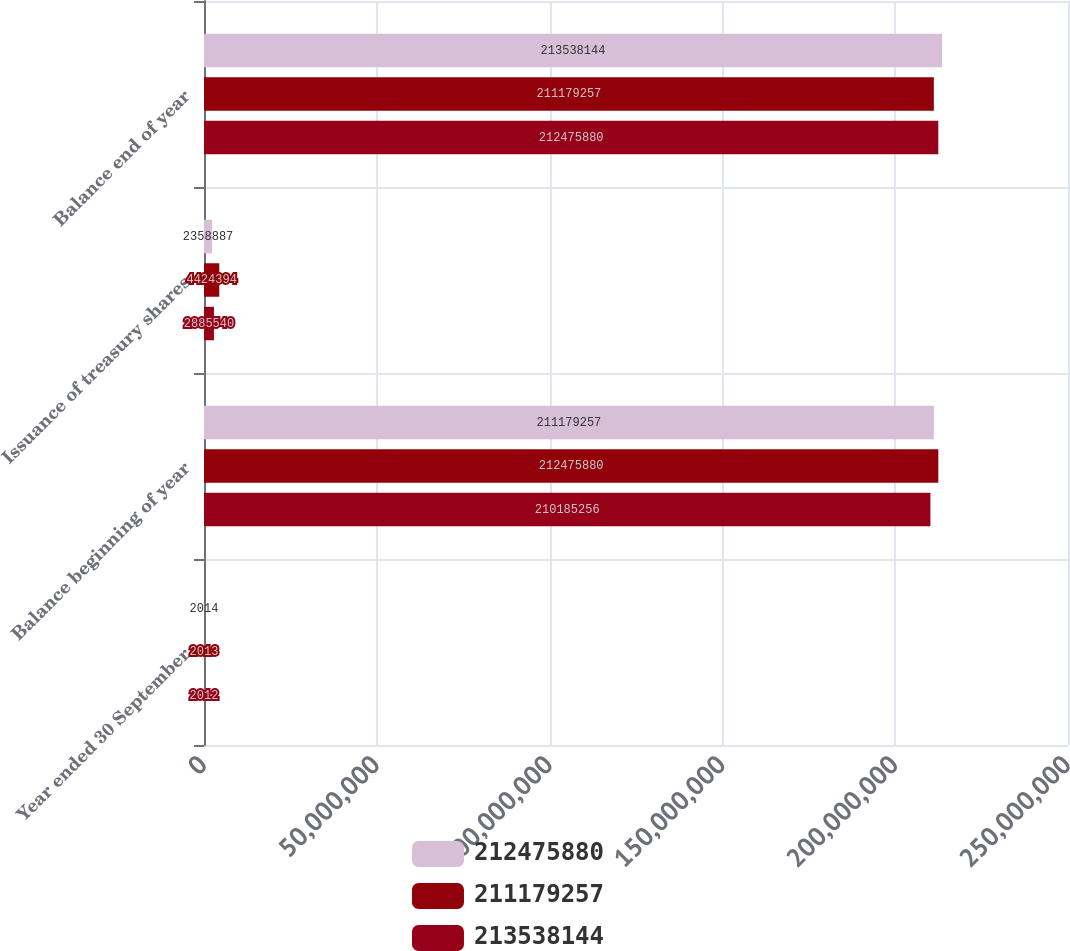Convert chart to OTSL. <chart><loc_0><loc_0><loc_500><loc_500><stacked_bar_chart><ecel><fcel>Year ended 30 September<fcel>Balance beginning of year<fcel>Issuance of treasury shares<fcel>Balance end of year<nl><fcel>2.12476e+08<fcel>2014<fcel>2.11179e+08<fcel>2.35889e+06<fcel>2.13538e+08<nl><fcel>2.11179e+08<fcel>2013<fcel>2.12476e+08<fcel>4.42439e+06<fcel>2.11179e+08<nl><fcel>2.13538e+08<fcel>2012<fcel>2.10185e+08<fcel>2.88554e+06<fcel>2.12476e+08<nl></chart> 